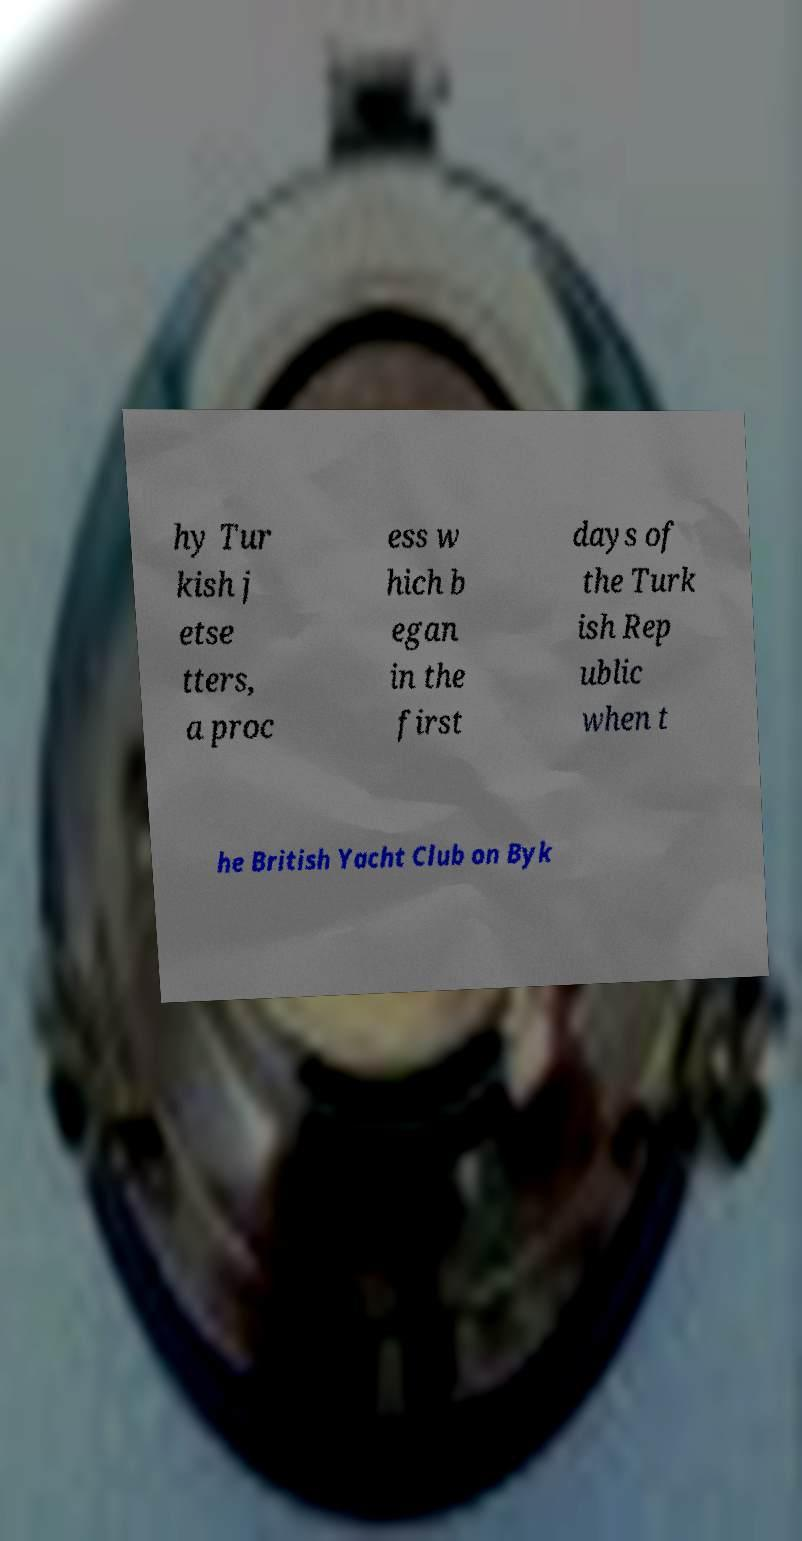Could you assist in decoding the text presented in this image and type it out clearly? hy Tur kish j etse tters, a proc ess w hich b egan in the first days of the Turk ish Rep ublic when t he British Yacht Club on Byk 